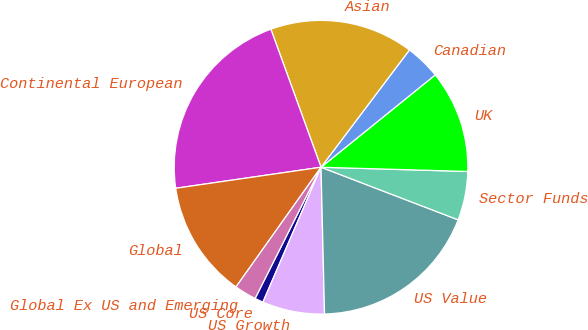Convert chart to OTSL. <chart><loc_0><loc_0><loc_500><loc_500><pie_chart><fcel>US Core<fcel>US Growth<fcel>US Value<fcel>Sector Funds<fcel>UK<fcel>Canadian<fcel>Asian<fcel>Continental European<fcel>Global<fcel>Global Ex US and Emerging<nl><fcel>0.94%<fcel>6.85%<fcel>18.79%<fcel>5.37%<fcel>11.28%<fcel>3.9%<fcel>15.83%<fcel>21.74%<fcel>12.88%<fcel>2.42%<nl></chart> 